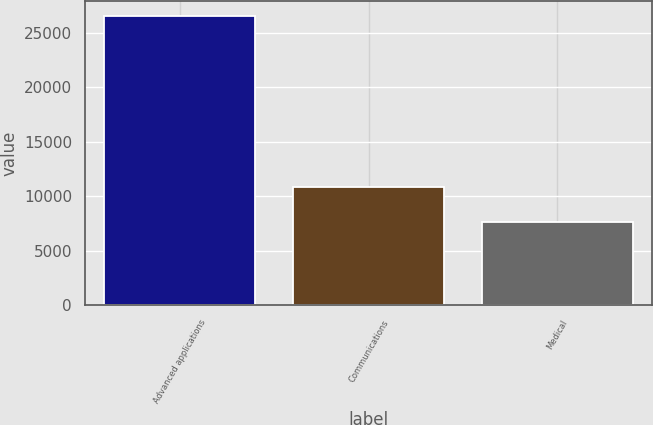<chart> <loc_0><loc_0><loc_500><loc_500><bar_chart><fcel>Advanced applications<fcel>Communications<fcel>Medical<nl><fcel>26557<fcel>10867<fcel>7606<nl></chart> 